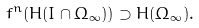<formula> <loc_0><loc_0><loc_500><loc_500>f ^ { n } ( H ( I \cap \Omega _ { \infty } ) ) \supset H ( \Omega _ { \infty } ) .</formula> 